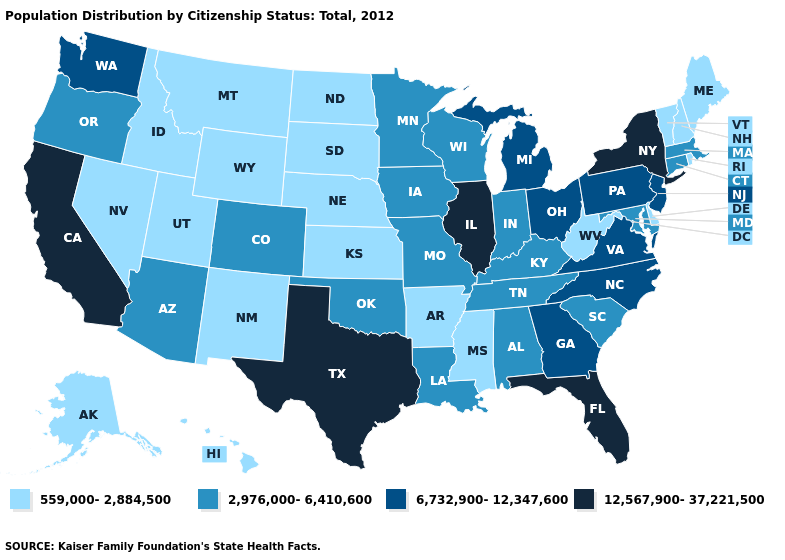Does Utah have the lowest value in the USA?
Keep it brief. Yes. Does Colorado have the lowest value in the West?
Answer briefly. No. What is the value of Missouri?
Write a very short answer. 2,976,000-6,410,600. What is the highest value in the USA?
Quick response, please. 12,567,900-37,221,500. Name the states that have a value in the range 2,976,000-6,410,600?
Write a very short answer. Alabama, Arizona, Colorado, Connecticut, Indiana, Iowa, Kentucky, Louisiana, Maryland, Massachusetts, Minnesota, Missouri, Oklahoma, Oregon, South Carolina, Tennessee, Wisconsin. Among the states that border Kentucky , does West Virginia have the lowest value?
Write a very short answer. Yes. Among the states that border New Mexico , which have the highest value?
Write a very short answer. Texas. What is the highest value in states that border Illinois?
Quick response, please. 2,976,000-6,410,600. Name the states that have a value in the range 6,732,900-12,347,600?
Be succinct. Georgia, Michigan, New Jersey, North Carolina, Ohio, Pennsylvania, Virginia, Washington. Does Vermont have a higher value than Idaho?
Quick response, please. No. Which states have the lowest value in the West?
Be succinct. Alaska, Hawaii, Idaho, Montana, Nevada, New Mexico, Utah, Wyoming. What is the highest value in the USA?
Short answer required. 12,567,900-37,221,500. Among the states that border Arizona , which have the lowest value?
Write a very short answer. Nevada, New Mexico, Utah. What is the highest value in the USA?
Give a very brief answer. 12,567,900-37,221,500. What is the value of Idaho?
Keep it brief. 559,000-2,884,500. 